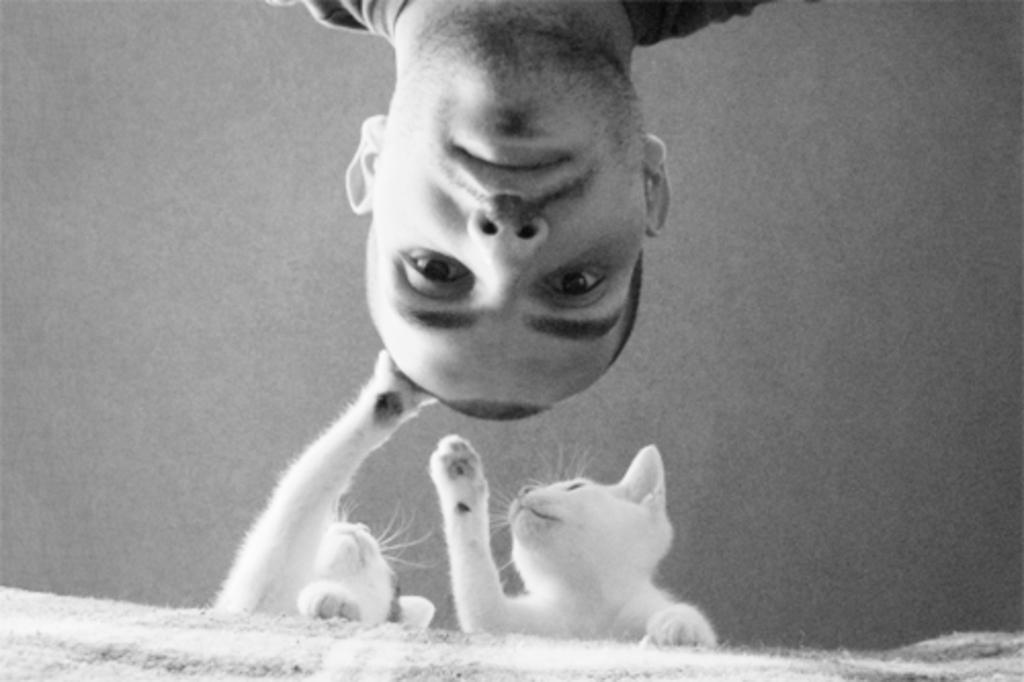In one or two sentences, can you explain what this image depicts? In this picture there is a man who is wearing t-shirt. At the bottom there are two white cats which are standing near to the bed. 